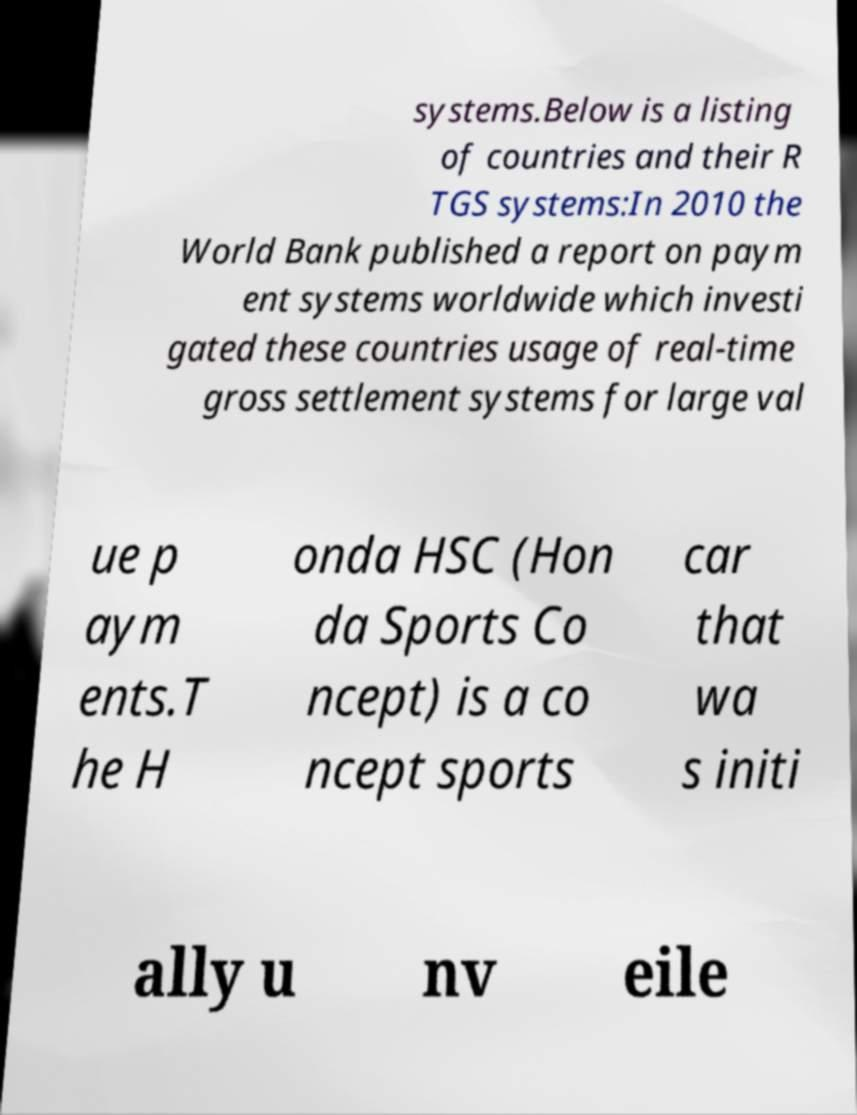Can you accurately transcribe the text from the provided image for me? systems.Below is a listing of countries and their R TGS systems:In 2010 the World Bank published a report on paym ent systems worldwide which investi gated these countries usage of real-time gross settlement systems for large val ue p aym ents.T he H onda HSC (Hon da Sports Co ncept) is a co ncept sports car that wa s initi ally u nv eile 